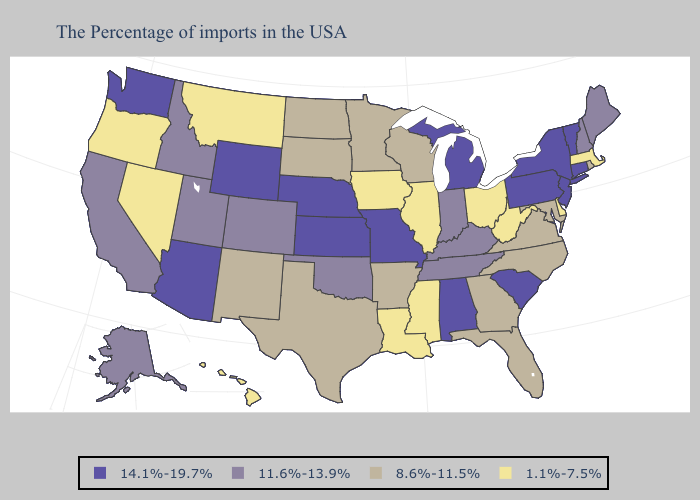What is the lowest value in the West?
Write a very short answer. 1.1%-7.5%. Name the states that have a value in the range 14.1%-19.7%?
Give a very brief answer. Vermont, Connecticut, New York, New Jersey, Pennsylvania, South Carolina, Michigan, Alabama, Missouri, Kansas, Nebraska, Wyoming, Arizona, Washington. Does Nebraska have the lowest value in the MidWest?
Concise answer only. No. Does Louisiana have the same value as Hawaii?
Write a very short answer. Yes. Name the states that have a value in the range 8.6%-11.5%?
Answer briefly. Rhode Island, Maryland, Virginia, North Carolina, Florida, Georgia, Wisconsin, Arkansas, Minnesota, Texas, South Dakota, North Dakota, New Mexico. What is the value of Maine?
Concise answer only. 11.6%-13.9%. Which states have the lowest value in the West?
Answer briefly. Montana, Nevada, Oregon, Hawaii. Among the states that border Alabama , which have the lowest value?
Keep it brief. Mississippi. Name the states that have a value in the range 1.1%-7.5%?
Quick response, please. Massachusetts, Delaware, West Virginia, Ohio, Illinois, Mississippi, Louisiana, Iowa, Montana, Nevada, Oregon, Hawaii. Name the states that have a value in the range 11.6%-13.9%?
Quick response, please. Maine, New Hampshire, Kentucky, Indiana, Tennessee, Oklahoma, Colorado, Utah, Idaho, California, Alaska. What is the lowest value in states that border Nevada?
Give a very brief answer. 1.1%-7.5%. What is the lowest value in the West?
Be succinct. 1.1%-7.5%. What is the value of Connecticut?
Concise answer only. 14.1%-19.7%. Among the states that border Nevada , does Utah have the lowest value?
Quick response, please. No. 